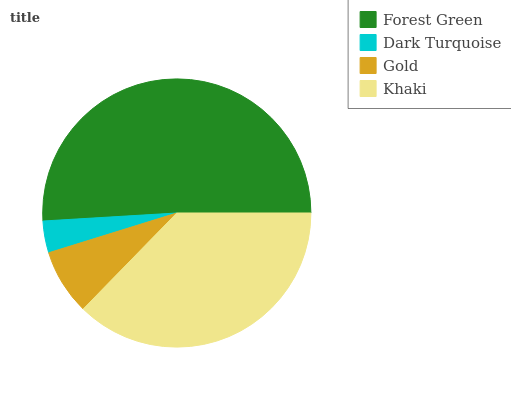Is Dark Turquoise the minimum?
Answer yes or no. Yes. Is Forest Green the maximum?
Answer yes or no. Yes. Is Gold the minimum?
Answer yes or no. No. Is Gold the maximum?
Answer yes or no. No. Is Gold greater than Dark Turquoise?
Answer yes or no. Yes. Is Dark Turquoise less than Gold?
Answer yes or no. Yes. Is Dark Turquoise greater than Gold?
Answer yes or no. No. Is Gold less than Dark Turquoise?
Answer yes or no. No. Is Khaki the high median?
Answer yes or no. Yes. Is Gold the low median?
Answer yes or no. Yes. Is Gold the high median?
Answer yes or no. No. Is Khaki the low median?
Answer yes or no. No. 